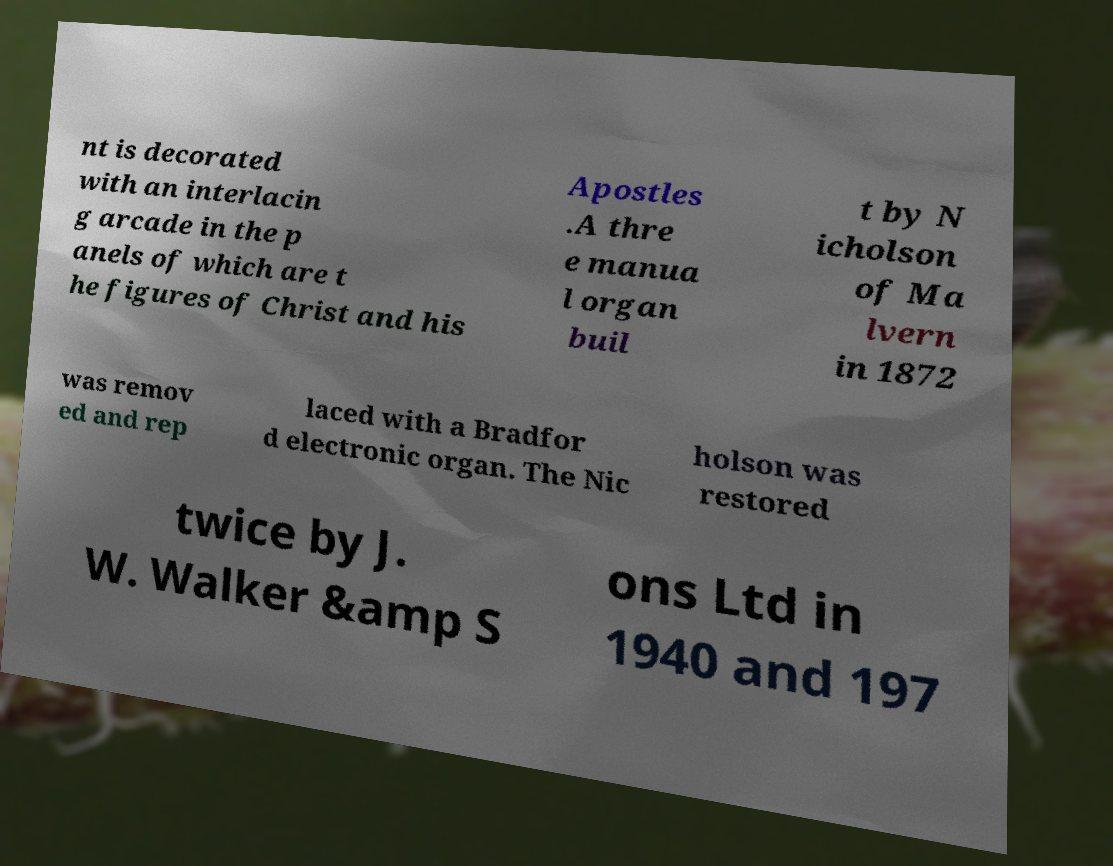For documentation purposes, I need the text within this image transcribed. Could you provide that? nt is decorated with an interlacin g arcade in the p anels of which are t he figures of Christ and his Apostles .A thre e manua l organ buil t by N icholson of Ma lvern in 1872 was remov ed and rep laced with a Bradfor d electronic organ. The Nic holson was restored twice by J. W. Walker &amp S ons Ltd in 1940 and 197 